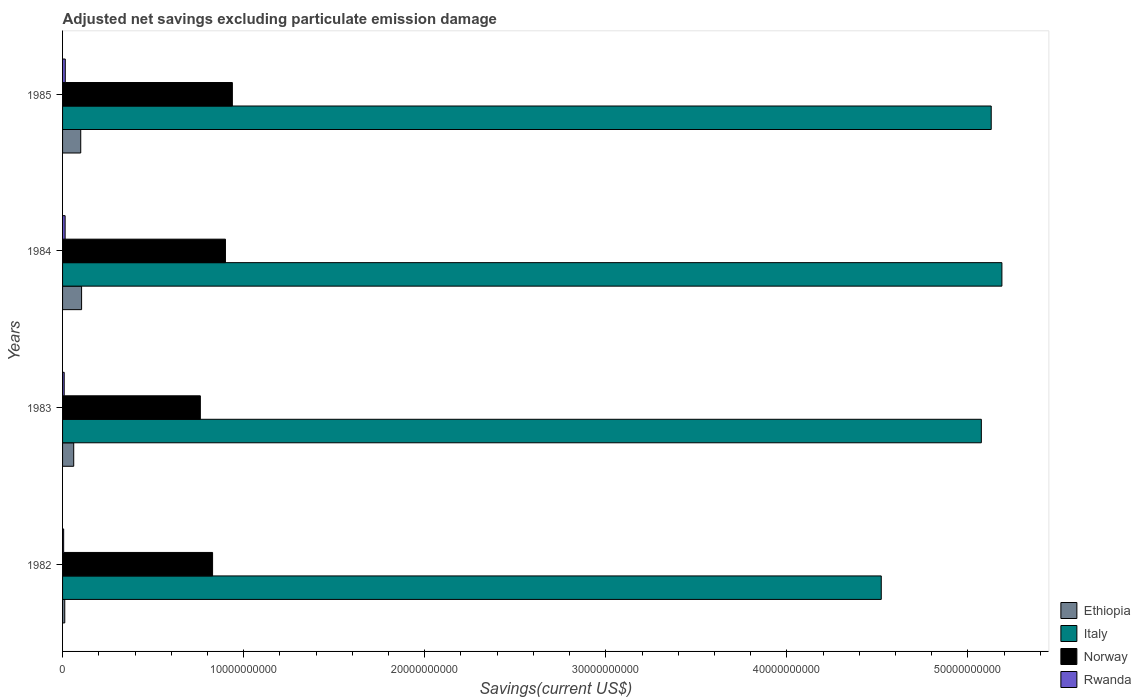How many different coloured bars are there?
Give a very brief answer. 4. How many bars are there on the 3rd tick from the bottom?
Your response must be concise. 4. In how many cases, is the number of bars for a given year not equal to the number of legend labels?
Provide a succinct answer. 0. What is the adjusted net savings in Norway in 1984?
Provide a succinct answer. 9.00e+09. Across all years, what is the maximum adjusted net savings in Ethiopia?
Ensure brevity in your answer.  1.05e+09. Across all years, what is the minimum adjusted net savings in Rwanda?
Provide a short and direct response. 5.99e+07. What is the total adjusted net savings in Italy in the graph?
Your answer should be compact. 1.99e+11. What is the difference between the adjusted net savings in Norway in 1983 and that in 1985?
Offer a terse response. -1.77e+09. What is the difference between the adjusted net savings in Rwanda in 1985 and the adjusted net savings in Norway in 1983?
Your response must be concise. -7.46e+09. What is the average adjusted net savings in Rwanda per year?
Offer a terse response. 1.10e+08. In the year 1982, what is the difference between the adjusted net savings in Rwanda and adjusted net savings in Italy?
Make the answer very short. -4.52e+1. What is the ratio of the adjusted net savings in Norway in 1983 to that in 1985?
Provide a short and direct response. 0.81. What is the difference between the highest and the second highest adjusted net savings in Norway?
Give a very brief answer. 3.82e+08. What is the difference between the highest and the lowest adjusted net savings in Norway?
Make the answer very short. 1.77e+09. In how many years, is the adjusted net savings in Italy greater than the average adjusted net savings in Italy taken over all years?
Provide a short and direct response. 3. Is the sum of the adjusted net savings in Norway in 1983 and 1984 greater than the maximum adjusted net savings in Ethiopia across all years?
Give a very brief answer. Yes. What does the 4th bar from the bottom in 1985 represents?
Provide a short and direct response. Rwanda. Is it the case that in every year, the sum of the adjusted net savings in Italy and adjusted net savings in Ethiopia is greater than the adjusted net savings in Norway?
Make the answer very short. Yes. How many bars are there?
Your answer should be compact. 16. What is the difference between two consecutive major ticks on the X-axis?
Offer a terse response. 1.00e+1. Does the graph contain any zero values?
Ensure brevity in your answer.  No. How are the legend labels stacked?
Offer a terse response. Vertical. What is the title of the graph?
Make the answer very short. Adjusted net savings excluding particulate emission damage. What is the label or title of the X-axis?
Your answer should be very brief. Savings(current US$). What is the Savings(current US$) of Ethiopia in 1982?
Give a very brief answer. 1.22e+08. What is the Savings(current US$) in Italy in 1982?
Your answer should be very brief. 4.52e+1. What is the Savings(current US$) in Norway in 1982?
Ensure brevity in your answer.  8.28e+09. What is the Savings(current US$) of Rwanda in 1982?
Give a very brief answer. 5.99e+07. What is the Savings(current US$) in Ethiopia in 1983?
Provide a short and direct response. 6.16e+08. What is the Savings(current US$) in Italy in 1983?
Your answer should be compact. 5.07e+1. What is the Savings(current US$) in Norway in 1983?
Offer a terse response. 7.61e+09. What is the Savings(current US$) in Rwanda in 1983?
Your answer should be very brief. 9.06e+07. What is the Savings(current US$) of Ethiopia in 1984?
Your answer should be very brief. 1.05e+09. What is the Savings(current US$) in Italy in 1984?
Make the answer very short. 5.19e+1. What is the Savings(current US$) of Norway in 1984?
Provide a short and direct response. 9.00e+09. What is the Savings(current US$) in Rwanda in 1984?
Your response must be concise. 1.42e+08. What is the Savings(current US$) of Ethiopia in 1985?
Ensure brevity in your answer.  1.00e+09. What is the Savings(current US$) of Italy in 1985?
Ensure brevity in your answer.  5.13e+1. What is the Savings(current US$) of Norway in 1985?
Give a very brief answer. 9.38e+09. What is the Savings(current US$) of Rwanda in 1985?
Provide a succinct answer. 1.50e+08. Across all years, what is the maximum Savings(current US$) in Ethiopia?
Offer a terse response. 1.05e+09. Across all years, what is the maximum Savings(current US$) in Italy?
Provide a succinct answer. 5.19e+1. Across all years, what is the maximum Savings(current US$) in Norway?
Offer a terse response. 9.38e+09. Across all years, what is the maximum Savings(current US$) in Rwanda?
Offer a very short reply. 1.50e+08. Across all years, what is the minimum Savings(current US$) in Ethiopia?
Make the answer very short. 1.22e+08. Across all years, what is the minimum Savings(current US$) of Italy?
Your answer should be very brief. 4.52e+1. Across all years, what is the minimum Savings(current US$) of Norway?
Keep it short and to the point. 7.61e+09. Across all years, what is the minimum Savings(current US$) of Rwanda?
Your answer should be compact. 5.99e+07. What is the total Savings(current US$) in Ethiopia in the graph?
Offer a very short reply. 2.79e+09. What is the total Savings(current US$) of Italy in the graph?
Make the answer very short. 1.99e+11. What is the total Savings(current US$) of Norway in the graph?
Offer a very short reply. 3.43e+1. What is the total Savings(current US$) in Rwanda in the graph?
Give a very brief answer. 4.42e+08. What is the difference between the Savings(current US$) of Ethiopia in 1982 and that in 1983?
Your answer should be very brief. -4.94e+08. What is the difference between the Savings(current US$) in Italy in 1982 and that in 1983?
Your answer should be compact. -5.53e+09. What is the difference between the Savings(current US$) in Norway in 1982 and that in 1983?
Provide a succinct answer. 6.76e+08. What is the difference between the Savings(current US$) in Rwanda in 1982 and that in 1983?
Give a very brief answer. -3.07e+07. What is the difference between the Savings(current US$) of Ethiopia in 1982 and that in 1984?
Provide a short and direct response. -9.29e+08. What is the difference between the Savings(current US$) of Italy in 1982 and that in 1984?
Keep it short and to the point. -6.66e+09. What is the difference between the Savings(current US$) of Norway in 1982 and that in 1984?
Your answer should be very brief. -7.10e+08. What is the difference between the Savings(current US$) of Rwanda in 1982 and that in 1984?
Your answer should be compact. -8.18e+07. What is the difference between the Savings(current US$) of Ethiopia in 1982 and that in 1985?
Your answer should be very brief. -8.82e+08. What is the difference between the Savings(current US$) in Italy in 1982 and that in 1985?
Provide a short and direct response. -6.07e+09. What is the difference between the Savings(current US$) of Norway in 1982 and that in 1985?
Keep it short and to the point. -1.09e+09. What is the difference between the Savings(current US$) of Rwanda in 1982 and that in 1985?
Make the answer very short. -8.97e+07. What is the difference between the Savings(current US$) in Ethiopia in 1983 and that in 1984?
Ensure brevity in your answer.  -4.35e+08. What is the difference between the Savings(current US$) of Italy in 1983 and that in 1984?
Give a very brief answer. -1.14e+09. What is the difference between the Savings(current US$) in Norway in 1983 and that in 1984?
Make the answer very short. -1.39e+09. What is the difference between the Savings(current US$) in Rwanda in 1983 and that in 1984?
Provide a succinct answer. -5.12e+07. What is the difference between the Savings(current US$) in Ethiopia in 1983 and that in 1985?
Provide a short and direct response. -3.88e+08. What is the difference between the Savings(current US$) in Italy in 1983 and that in 1985?
Give a very brief answer. -5.46e+08. What is the difference between the Savings(current US$) of Norway in 1983 and that in 1985?
Offer a terse response. -1.77e+09. What is the difference between the Savings(current US$) in Rwanda in 1983 and that in 1985?
Make the answer very short. -5.90e+07. What is the difference between the Savings(current US$) of Ethiopia in 1984 and that in 1985?
Keep it short and to the point. 4.70e+07. What is the difference between the Savings(current US$) of Italy in 1984 and that in 1985?
Keep it short and to the point. 5.90e+08. What is the difference between the Savings(current US$) of Norway in 1984 and that in 1985?
Your response must be concise. -3.82e+08. What is the difference between the Savings(current US$) of Rwanda in 1984 and that in 1985?
Keep it short and to the point. -7.88e+06. What is the difference between the Savings(current US$) of Ethiopia in 1982 and the Savings(current US$) of Italy in 1983?
Your response must be concise. -5.06e+1. What is the difference between the Savings(current US$) in Ethiopia in 1982 and the Savings(current US$) in Norway in 1983?
Offer a very short reply. -7.49e+09. What is the difference between the Savings(current US$) of Ethiopia in 1982 and the Savings(current US$) of Rwanda in 1983?
Provide a short and direct response. 3.12e+07. What is the difference between the Savings(current US$) of Italy in 1982 and the Savings(current US$) of Norway in 1983?
Provide a succinct answer. 3.76e+1. What is the difference between the Savings(current US$) in Italy in 1982 and the Savings(current US$) in Rwanda in 1983?
Keep it short and to the point. 4.51e+1. What is the difference between the Savings(current US$) of Norway in 1982 and the Savings(current US$) of Rwanda in 1983?
Offer a terse response. 8.19e+09. What is the difference between the Savings(current US$) of Ethiopia in 1982 and the Savings(current US$) of Italy in 1984?
Give a very brief answer. -5.18e+1. What is the difference between the Savings(current US$) in Ethiopia in 1982 and the Savings(current US$) in Norway in 1984?
Your response must be concise. -8.87e+09. What is the difference between the Savings(current US$) of Ethiopia in 1982 and the Savings(current US$) of Rwanda in 1984?
Your response must be concise. -2.00e+07. What is the difference between the Savings(current US$) of Italy in 1982 and the Savings(current US$) of Norway in 1984?
Your answer should be very brief. 3.62e+1. What is the difference between the Savings(current US$) of Italy in 1982 and the Savings(current US$) of Rwanda in 1984?
Provide a succinct answer. 4.51e+1. What is the difference between the Savings(current US$) in Norway in 1982 and the Savings(current US$) in Rwanda in 1984?
Your response must be concise. 8.14e+09. What is the difference between the Savings(current US$) of Ethiopia in 1982 and the Savings(current US$) of Italy in 1985?
Your answer should be very brief. -5.12e+1. What is the difference between the Savings(current US$) in Ethiopia in 1982 and the Savings(current US$) in Norway in 1985?
Provide a short and direct response. -9.25e+09. What is the difference between the Savings(current US$) in Ethiopia in 1982 and the Savings(current US$) in Rwanda in 1985?
Offer a terse response. -2.78e+07. What is the difference between the Savings(current US$) in Italy in 1982 and the Savings(current US$) in Norway in 1985?
Your answer should be very brief. 3.58e+1. What is the difference between the Savings(current US$) of Italy in 1982 and the Savings(current US$) of Rwanda in 1985?
Your answer should be very brief. 4.51e+1. What is the difference between the Savings(current US$) of Norway in 1982 and the Savings(current US$) of Rwanda in 1985?
Your answer should be very brief. 8.14e+09. What is the difference between the Savings(current US$) of Ethiopia in 1983 and the Savings(current US$) of Italy in 1984?
Your response must be concise. -5.13e+1. What is the difference between the Savings(current US$) of Ethiopia in 1983 and the Savings(current US$) of Norway in 1984?
Provide a short and direct response. -8.38e+09. What is the difference between the Savings(current US$) of Ethiopia in 1983 and the Savings(current US$) of Rwanda in 1984?
Keep it short and to the point. 4.74e+08. What is the difference between the Savings(current US$) of Italy in 1983 and the Savings(current US$) of Norway in 1984?
Offer a very short reply. 4.17e+1. What is the difference between the Savings(current US$) of Italy in 1983 and the Savings(current US$) of Rwanda in 1984?
Your answer should be compact. 5.06e+1. What is the difference between the Savings(current US$) of Norway in 1983 and the Savings(current US$) of Rwanda in 1984?
Offer a terse response. 7.47e+09. What is the difference between the Savings(current US$) of Ethiopia in 1983 and the Savings(current US$) of Italy in 1985?
Provide a short and direct response. -5.07e+1. What is the difference between the Savings(current US$) of Ethiopia in 1983 and the Savings(current US$) of Norway in 1985?
Give a very brief answer. -8.76e+09. What is the difference between the Savings(current US$) of Ethiopia in 1983 and the Savings(current US$) of Rwanda in 1985?
Provide a short and direct response. 4.66e+08. What is the difference between the Savings(current US$) of Italy in 1983 and the Savings(current US$) of Norway in 1985?
Your answer should be very brief. 4.14e+1. What is the difference between the Savings(current US$) in Italy in 1983 and the Savings(current US$) in Rwanda in 1985?
Make the answer very short. 5.06e+1. What is the difference between the Savings(current US$) in Norway in 1983 and the Savings(current US$) in Rwanda in 1985?
Keep it short and to the point. 7.46e+09. What is the difference between the Savings(current US$) in Ethiopia in 1984 and the Savings(current US$) in Italy in 1985?
Your answer should be very brief. -5.02e+1. What is the difference between the Savings(current US$) of Ethiopia in 1984 and the Savings(current US$) of Norway in 1985?
Give a very brief answer. -8.33e+09. What is the difference between the Savings(current US$) of Ethiopia in 1984 and the Savings(current US$) of Rwanda in 1985?
Your answer should be very brief. 9.01e+08. What is the difference between the Savings(current US$) of Italy in 1984 and the Savings(current US$) of Norway in 1985?
Your answer should be very brief. 4.25e+1. What is the difference between the Savings(current US$) of Italy in 1984 and the Savings(current US$) of Rwanda in 1985?
Keep it short and to the point. 5.17e+1. What is the difference between the Savings(current US$) in Norway in 1984 and the Savings(current US$) in Rwanda in 1985?
Provide a short and direct response. 8.85e+09. What is the average Savings(current US$) in Ethiopia per year?
Keep it short and to the point. 6.98e+08. What is the average Savings(current US$) in Italy per year?
Offer a very short reply. 4.98e+1. What is the average Savings(current US$) of Norway per year?
Ensure brevity in your answer.  8.57e+09. What is the average Savings(current US$) of Rwanda per year?
Keep it short and to the point. 1.10e+08. In the year 1982, what is the difference between the Savings(current US$) of Ethiopia and Savings(current US$) of Italy?
Offer a very short reply. -4.51e+1. In the year 1982, what is the difference between the Savings(current US$) of Ethiopia and Savings(current US$) of Norway?
Your answer should be very brief. -8.16e+09. In the year 1982, what is the difference between the Savings(current US$) of Ethiopia and Savings(current US$) of Rwanda?
Give a very brief answer. 6.19e+07. In the year 1982, what is the difference between the Savings(current US$) in Italy and Savings(current US$) in Norway?
Give a very brief answer. 3.69e+1. In the year 1982, what is the difference between the Savings(current US$) of Italy and Savings(current US$) of Rwanda?
Make the answer very short. 4.52e+1. In the year 1982, what is the difference between the Savings(current US$) of Norway and Savings(current US$) of Rwanda?
Make the answer very short. 8.22e+09. In the year 1983, what is the difference between the Savings(current US$) of Ethiopia and Savings(current US$) of Italy?
Ensure brevity in your answer.  -5.01e+1. In the year 1983, what is the difference between the Savings(current US$) in Ethiopia and Savings(current US$) in Norway?
Offer a terse response. -6.99e+09. In the year 1983, what is the difference between the Savings(current US$) in Ethiopia and Savings(current US$) in Rwanda?
Your answer should be very brief. 5.25e+08. In the year 1983, what is the difference between the Savings(current US$) in Italy and Savings(current US$) in Norway?
Make the answer very short. 4.31e+1. In the year 1983, what is the difference between the Savings(current US$) in Italy and Savings(current US$) in Rwanda?
Your answer should be compact. 5.06e+1. In the year 1983, what is the difference between the Savings(current US$) in Norway and Savings(current US$) in Rwanda?
Provide a short and direct response. 7.52e+09. In the year 1984, what is the difference between the Savings(current US$) of Ethiopia and Savings(current US$) of Italy?
Your response must be concise. -5.08e+1. In the year 1984, what is the difference between the Savings(current US$) in Ethiopia and Savings(current US$) in Norway?
Ensure brevity in your answer.  -7.94e+09. In the year 1984, what is the difference between the Savings(current US$) of Ethiopia and Savings(current US$) of Rwanda?
Make the answer very short. 9.09e+08. In the year 1984, what is the difference between the Savings(current US$) of Italy and Savings(current US$) of Norway?
Make the answer very short. 4.29e+1. In the year 1984, what is the difference between the Savings(current US$) of Italy and Savings(current US$) of Rwanda?
Make the answer very short. 5.17e+1. In the year 1984, what is the difference between the Savings(current US$) of Norway and Savings(current US$) of Rwanda?
Provide a short and direct response. 8.85e+09. In the year 1985, what is the difference between the Savings(current US$) in Ethiopia and Savings(current US$) in Italy?
Keep it short and to the point. -5.03e+1. In the year 1985, what is the difference between the Savings(current US$) in Ethiopia and Savings(current US$) in Norway?
Your answer should be very brief. -8.37e+09. In the year 1985, what is the difference between the Savings(current US$) in Ethiopia and Savings(current US$) in Rwanda?
Make the answer very short. 8.54e+08. In the year 1985, what is the difference between the Savings(current US$) of Italy and Savings(current US$) of Norway?
Give a very brief answer. 4.19e+1. In the year 1985, what is the difference between the Savings(current US$) in Italy and Savings(current US$) in Rwanda?
Make the answer very short. 5.11e+1. In the year 1985, what is the difference between the Savings(current US$) in Norway and Savings(current US$) in Rwanda?
Provide a short and direct response. 9.23e+09. What is the ratio of the Savings(current US$) in Ethiopia in 1982 to that in 1983?
Make the answer very short. 0.2. What is the ratio of the Savings(current US$) in Italy in 1982 to that in 1983?
Offer a terse response. 0.89. What is the ratio of the Savings(current US$) of Norway in 1982 to that in 1983?
Provide a succinct answer. 1.09. What is the ratio of the Savings(current US$) of Rwanda in 1982 to that in 1983?
Give a very brief answer. 0.66. What is the ratio of the Savings(current US$) in Ethiopia in 1982 to that in 1984?
Offer a terse response. 0.12. What is the ratio of the Savings(current US$) of Italy in 1982 to that in 1984?
Make the answer very short. 0.87. What is the ratio of the Savings(current US$) of Norway in 1982 to that in 1984?
Provide a short and direct response. 0.92. What is the ratio of the Savings(current US$) of Rwanda in 1982 to that in 1984?
Offer a very short reply. 0.42. What is the ratio of the Savings(current US$) in Ethiopia in 1982 to that in 1985?
Your response must be concise. 0.12. What is the ratio of the Savings(current US$) of Italy in 1982 to that in 1985?
Provide a short and direct response. 0.88. What is the ratio of the Savings(current US$) in Norway in 1982 to that in 1985?
Offer a terse response. 0.88. What is the ratio of the Savings(current US$) of Rwanda in 1982 to that in 1985?
Make the answer very short. 0.4. What is the ratio of the Savings(current US$) in Ethiopia in 1983 to that in 1984?
Offer a terse response. 0.59. What is the ratio of the Savings(current US$) in Italy in 1983 to that in 1984?
Offer a very short reply. 0.98. What is the ratio of the Savings(current US$) in Norway in 1983 to that in 1984?
Make the answer very short. 0.85. What is the ratio of the Savings(current US$) of Rwanda in 1983 to that in 1984?
Provide a succinct answer. 0.64. What is the ratio of the Savings(current US$) of Ethiopia in 1983 to that in 1985?
Offer a terse response. 0.61. What is the ratio of the Savings(current US$) of Norway in 1983 to that in 1985?
Ensure brevity in your answer.  0.81. What is the ratio of the Savings(current US$) in Rwanda in 1983 to that in 1985?
Your answer should be very brief. 0.61. What is the ratio of the Savings(current US$) in Ethiopia in 1984 to that in 1985?
Make the answer very short. 1.05. What is the ratio of the Savings(current US$) in Italy in 1984 to that in 1985?
Your response must be concise. 1.01. What is the ratio of the Savings(current US$) in Norway in 1984 to that in 1985?
Your response must be concise. 0.96. What is the ratio of the Savings(current US$) in Rwanda in 1984 to that in 1985?
Give a very brief answer. 0.95. What is the difference between the highest and the second highest Savings(current US$) of Ethiopia?
Provide a succinct answer. 4.70e+07. What is the difference between the highest and the second highest Savings(current US$) in Italy?
Make the answer very short. 5.90e+08. What is the difference between the highest and the second highest Savings(current US$) of Norway?
Offer a terse response. 3.82e+08. What is the difference between the highest and the second highest Savings(current US$) in Rwanda?
Your answer should be very brief. 7.88e+06. What is the difference between the highest and the lowest Savings(current US$) in Ethiopia?
Your answer should be very brief. 9.29e+08. What is the difference between the highest and the lowest Savings(current US$) of Italy?
Offer a terse response. 6.66e+09. What is the difference between the highest and the lowest Savings(current US$) in Norway?
Make the answer very short. 1.77e+09. What is the difference between the highest and the lowest Savings(current US$) of Rwanda?
Give a very brief answer. 8.97e+07. 